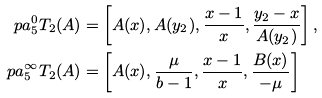Convert formula to latex. <formula><loc_0><loc_0><loc_500><loc_500>\ p a _ { 5 } ^ { 0 } T _ { 2 } ( A ) & = \left [ A ( x ) , A ( y _ { 2 } ) , \frac { x - 1 } { x } , \frac { y _ { 2 } - x } { A ( y _ { 2 } ) } \right ] , \\ \ p a _ { 5 } ^ { \infty } T _ { 2 } ( A ) & = \left [ A ( x ) , \frac { \mu } { b - 1 } , \frac { x - 1 } { x } , \frac { B ( x ) } { - \mu } \right ]</formula> 